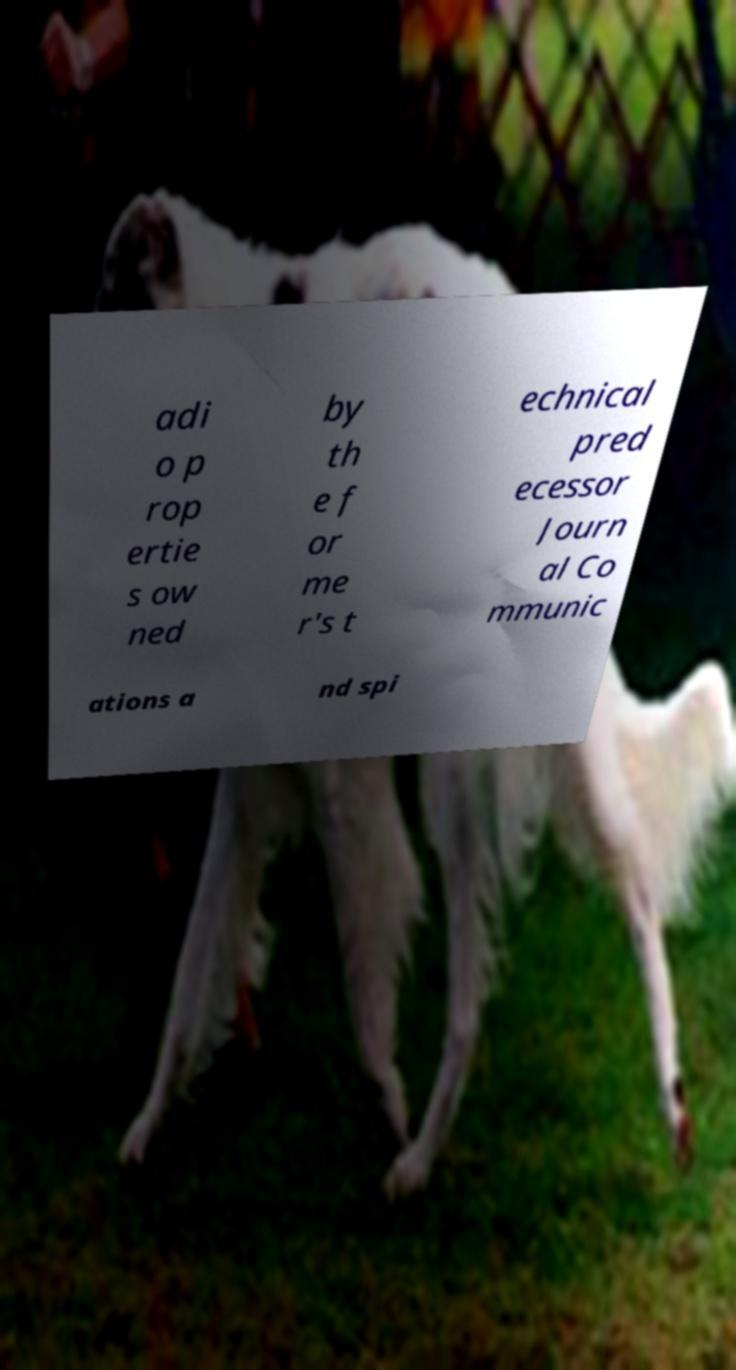I need the written content from this picture converted into text. Can you do that? adi o p rop ertie s ow ned by th e f or me r's t echnical pred ecessor Journ al Co mmunic ations a nd spi 